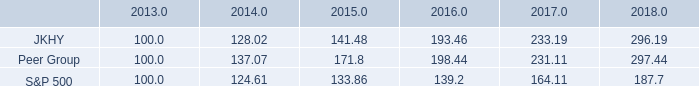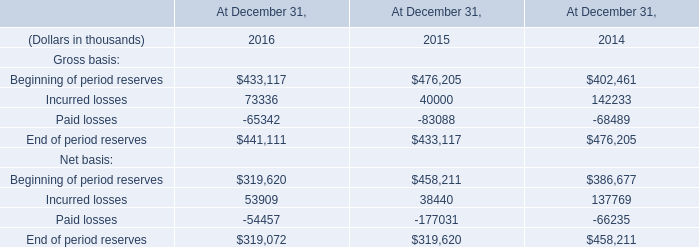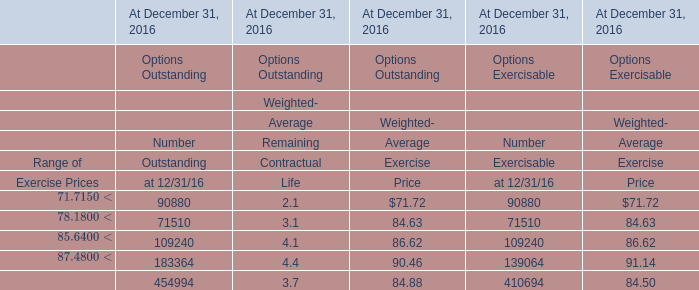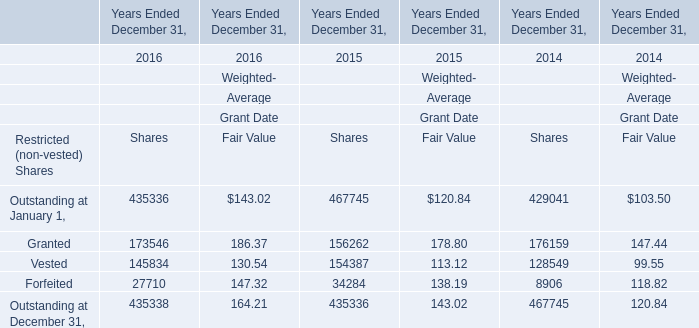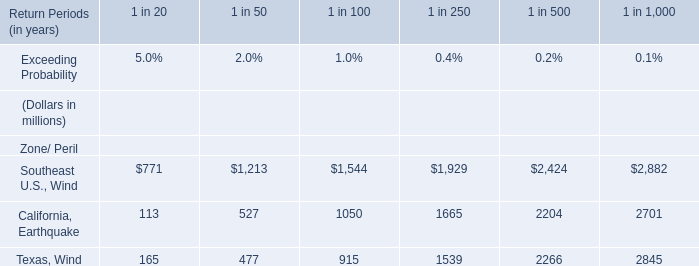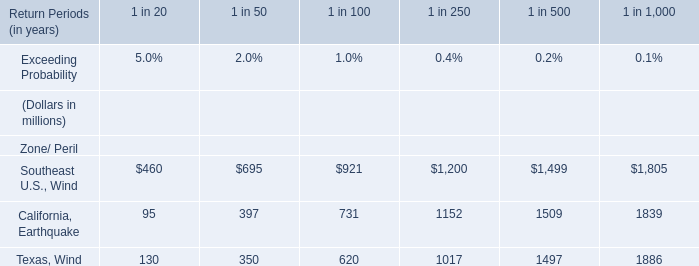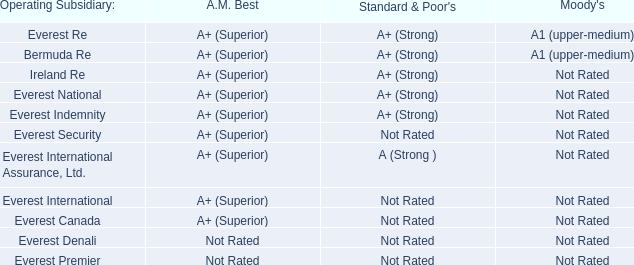What was the total amount of Shares in the range of 100000 and 200000 in 2016? 
Computations: (173546 + 145834)
Answer: 319380.0. 